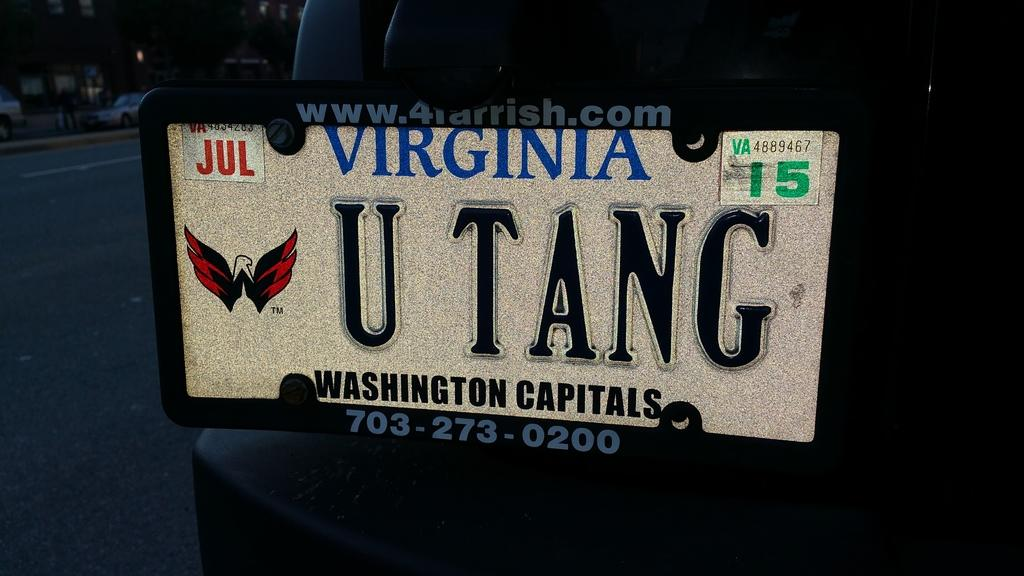<image>
Share a concise interpretation of the image provided. a virginia license plate has the letters U TANG on it 